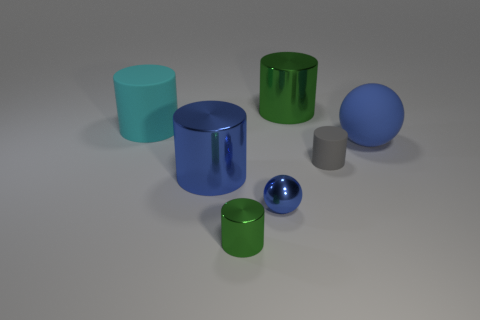Subtract all big cylinders. How many cylinders are left? 2 Add 1 small balls. How many objects exist? 8 Subtract 1 balls. How many balls are left? 1 Subtract all large matte things. Subtract all big blue objects. How many objects are left? 3 Add 7 large blue rubber things. How many large blue rubber things are left? 8 Add 2 yellow cylinders. How many yellow cylinders exist? 2 Subtract all cyan cylinders. How many cylinders are left? 4 Subtract 0 yellow blocks. How many objects are left? 7 Subtract all spheres. How many objects are left? 5 Subtract all brown cylinders. Subtract all blue cubes. How many cylinders are left? 5 